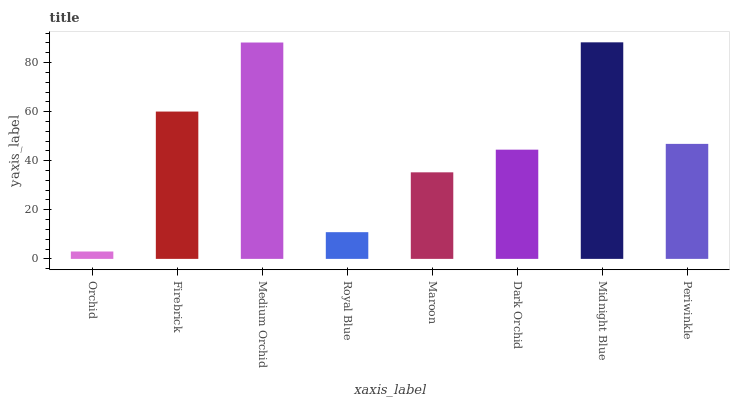Is Orchid the minimum?
Answer yes or no. Yes. Is Midnight Blue the maximum?
Answer yes or no. Yes. Is Firebrick the minimum?
Answer yes or no. No. Is Firebrick the maximum?
Answer yes or no. No. Is Firebrick greater than Orchid?
Answer yes or no. Yes. Is Orchid less than Firebrick?
Answer yes or no. Yes. Is Orchid greater than Firebrick?
Answer yes or no. No. Is Firebrick less than Orchid?
Answer yes or no. No. Is Periwinkle the high median?
Answer yes or no. Yes. Is Dark Orchid the low median?
Answer yes or no. Yes. Is Royal Blue the high median?
Answer yes or no. No. Is Maroon the low median?
Answer yes or no. No. 